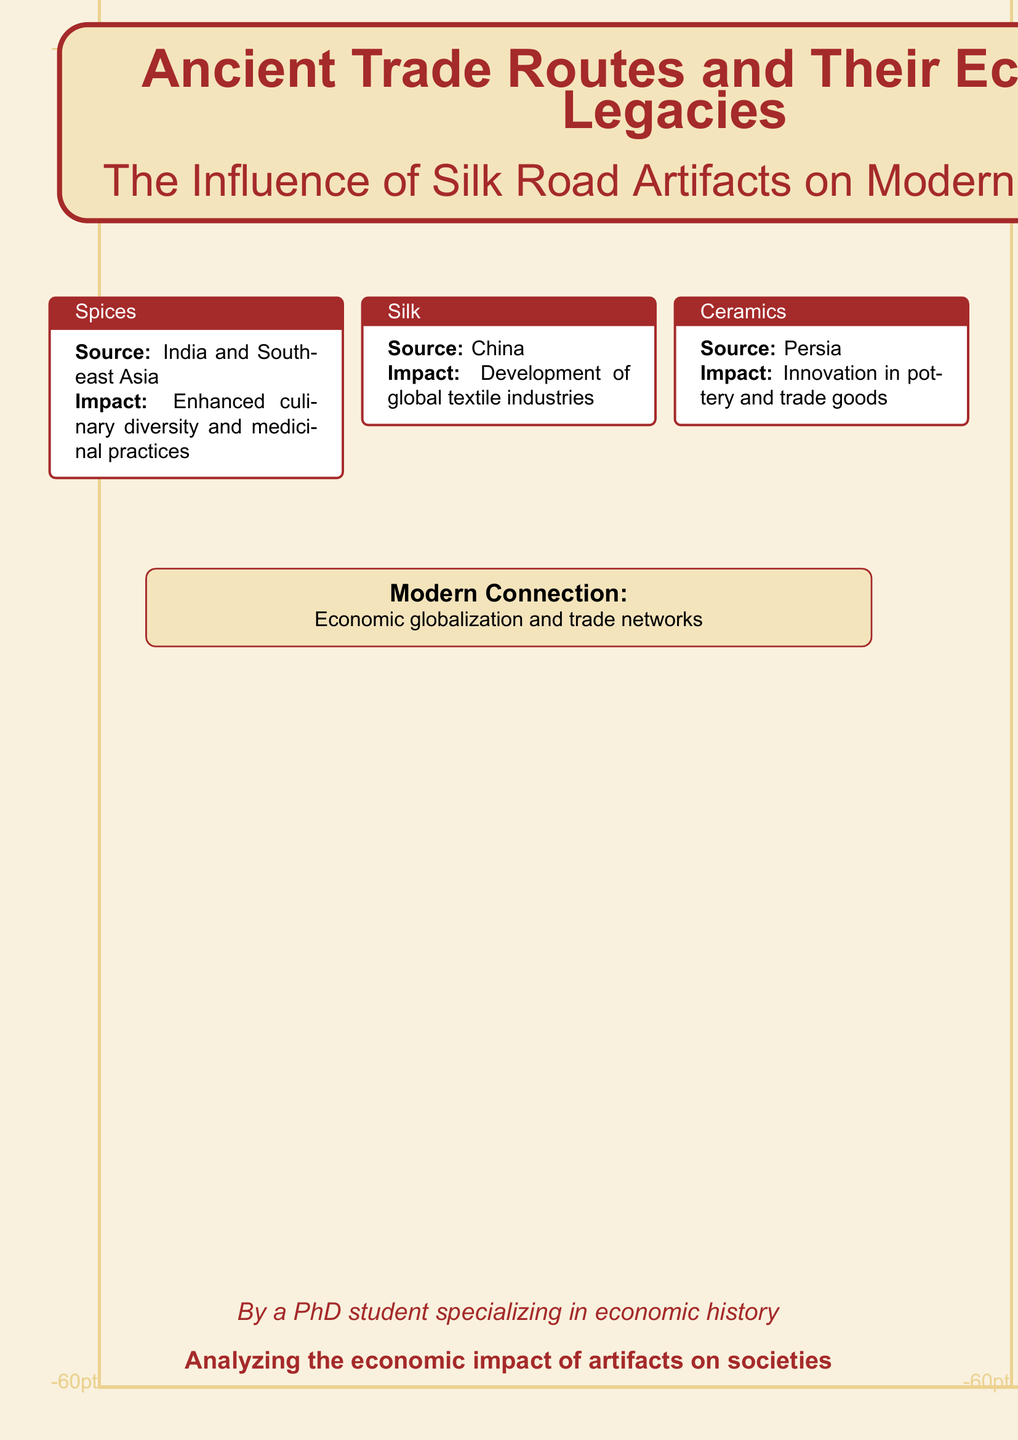What is the title of the book? The title of the book is prominently displayed at the top of the cover.
Answer: Ancient Trade Routes and Their Economic Legacies What is the subtitle of the book? The subtitle provides more detail about the book's focus, located directly below the title.
Answer: The Influence of Silk Road Artifacts on Modern Economies What artifacts are featured in the document? The document lists three specific artifacts and their impacts, which are outlined in individual boxes.
Answer: Spices, Silk, Ceramics Which region does the source of Spices come from? The document specifies the origin of Spices as noted in its designated box.
Answer: India and Southeast Asia What is one impact of Silk mentioned in the document? The impact of Silk is detailed within its respective information box on the cover.
Answer: Development of global textile industries What color scheme is primarily used in the background? The document's background color is described within its design elements.
Answer: Silkgold What type of design elements are used on the cover? The design elements on the cover are characterized by the structural format of the text boxes and illustrations.
Answer: Tcolorbox What economic concept is mentioned in the modern connection? This concept is highlighted in a separate box that relates the historical context to contemporary issues.
Answer: Economic globalization and trade networks Who authored the book? The author's name is mentioned in an italicized format towards the bottom of the cover.
Answer: A PhD student specializing in economic history 